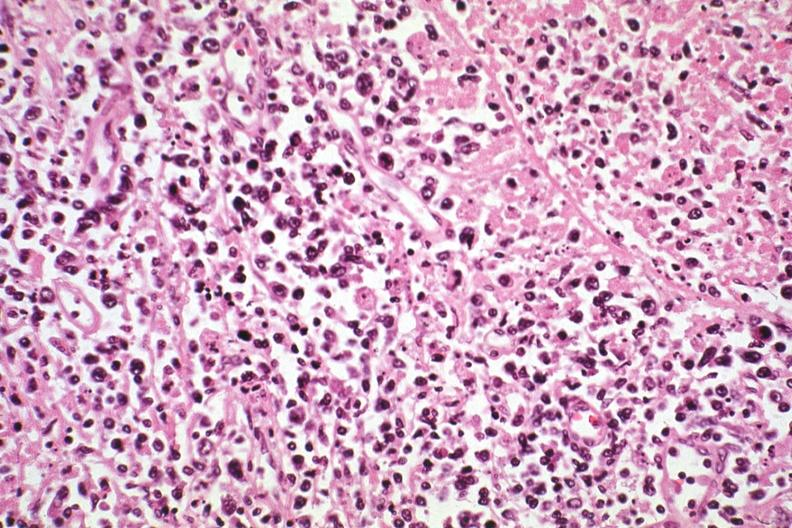does electron micrographs demonstrating fiber see other slides in file?
Answer the question using a single word or phrase. No 